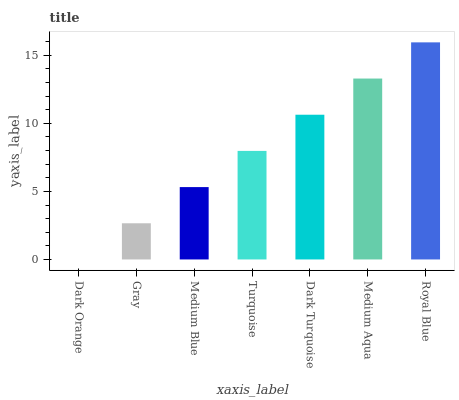Is Dark Orange the minimum?
Answer yes or no. Yes. Is Royal Blue the maximum?
Answer yes or no. Yes. Is Gray the minimum?
Answer yes or no. No. Is Gray the maximum?
Answer yes or no. No. Is Gray greater than Dark Orange?
Answer yes or no. Yes. Is Dark Orange less than Gray?
Answer yes or no. Yes. Is Dark Orange greater than Gray?
Answer yes or no. No. Is Gray less than Dark Orange?
Answer yes or no. No. Is Turquoise the high median?
Answer yes or no. Yes. Is Turquoise the low median?
Answer yes or no. Yes. Is Medium Aqua the high median?
Answer yes or no. No. Is Royal Blue the low median?
Answer yes or no. No. 